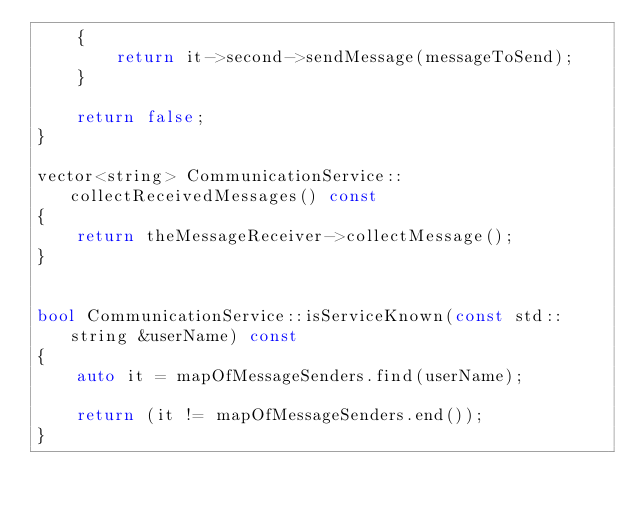Convert code to text. <code><loc_0><loc_0><loc_500><loc_500><_C++_>    {
        return it->second->sendMessage(messageToSend);
    }

    return false;
}

vector<string> CommunicationService::collectReceivedMessages() const
{
    return theMessageReceiver->collectMessage();
}


bool CommunicationService::isServiceKnown(const std::string &userName) const
{
    auto it = mapOfMessageSenders.find(userName);

    return (it != mapOfMessageSenders.end());
}
</code> 